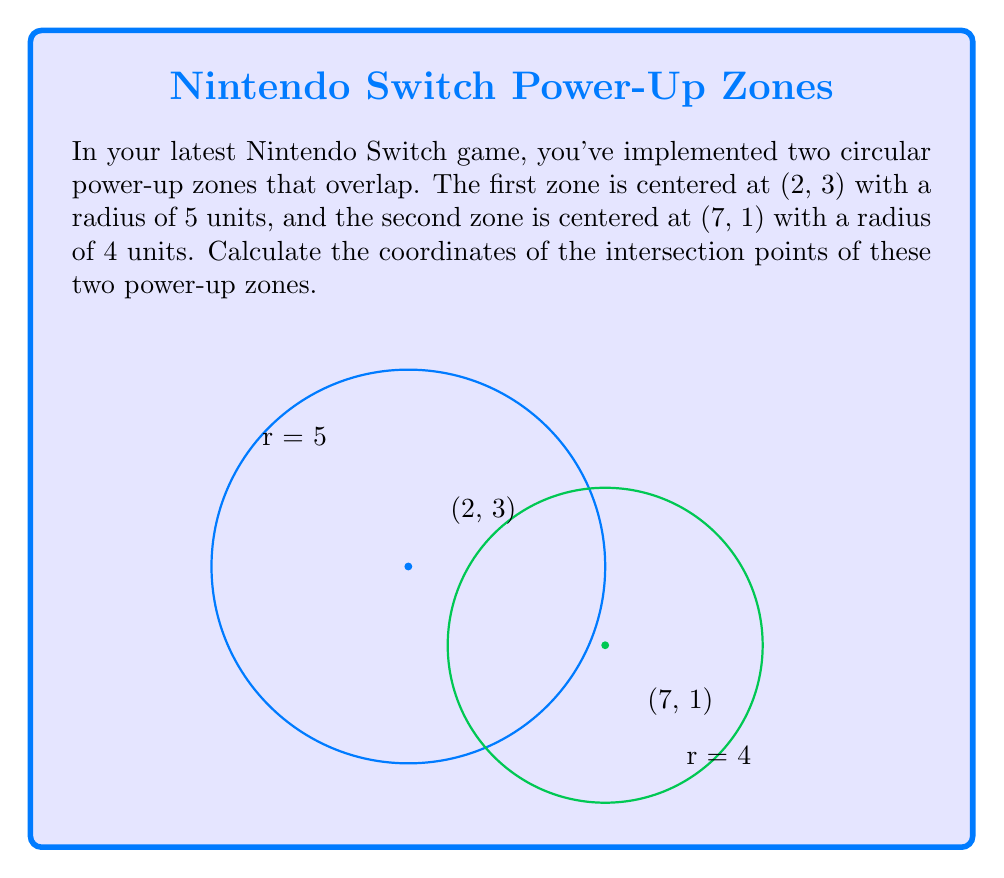Could you help me with this problem? To find the intersection points of two circles, we can follow these steps:

1) The general equation of a circle is $(x-h)^2 + (y-k)^2 = r^2$, where (h,k) is the center and r is the radius.

2) For the first circle: $(x-2)^2 + (y-3)^2 = 5^2 = 25$
   For the second circle: $(x-7)^2 + (y-1)^2 = 4^2 = 16$

3) Subtract the second equation from the first:
   $((x-2)^2 + (y-3)^2) - ((x-7)^2 + (y-1)^2) = 25 - 16$
   
4) Expand:
   $(x^2-4x+4 + y^2-6y+9) - (x^2-14x+49 + y^2-2y+1) = 9$
   
5) Simplify:
   $10x - 4y - 37 = 0$

6) This is the equation of the line passing through the intersection points. Substitute this into either circle equation. Let's use the first:

   $(x-2)^2 + ((\frac{10x-37}{4})-3)^2 = 25$

7) Expand and simplify (this step is complex and involves several algebraic manipulations):

   $256x^2 - 3584x + 12545 = 0$

8) This is a quadratic equation. Solve using the quadratic formula:
   $x = \frac{-b \pm \sqrt{b^2-4ac}}{2a}$

   $x = \frac{3584 \pm \sqrt{3584^2-4(256)(12545)}}{2(256)}$

9) Solve for x:
   $x \approx 5.54$ or $x \approx 8.46$

10) Substitute these x values back into the line equation to find corresponding y values:
    For $x = 5.54$: $y \approx 3.85$
    For $x = 8.46$: $y \approx 0.15$
Answer: $$(5.54, 3.85)$$ and $$(8.46, 0.15)$$ 